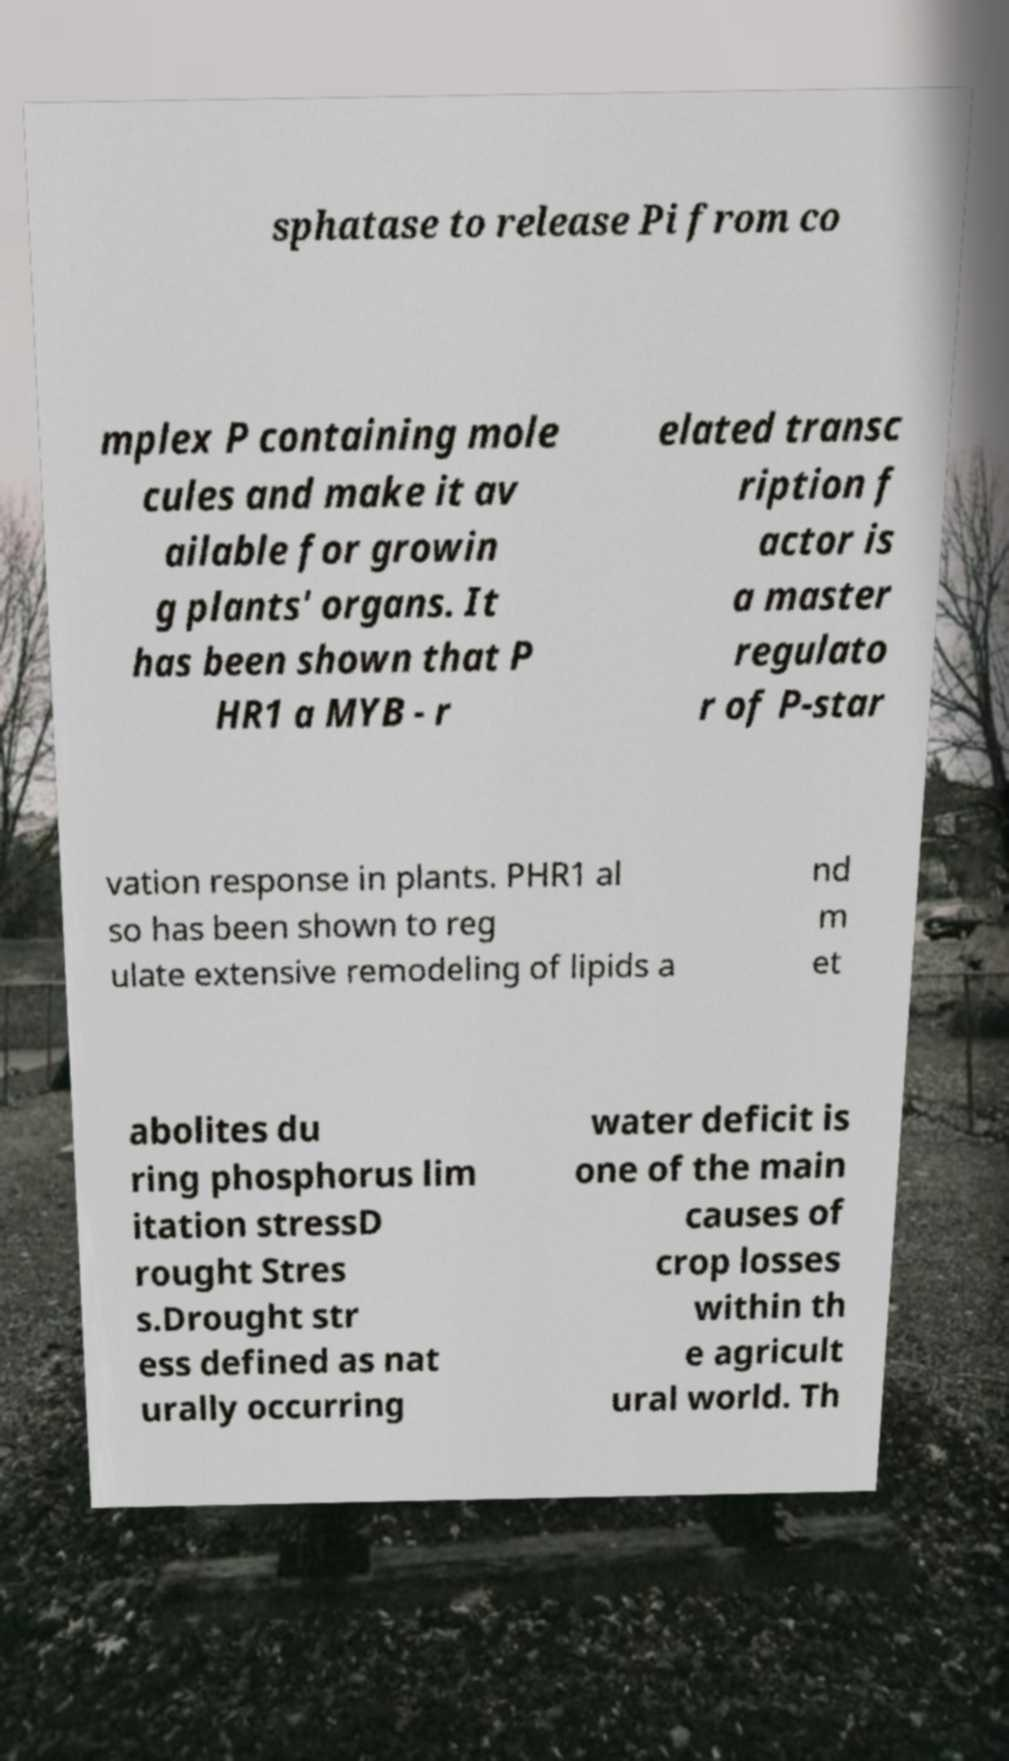What messages or text are displayed in this image? I need them in a readable, typed format. sphatase to release Pi from co mplex P containing mole cules and make it av ailable for growin g plants' organs. It has been shown that P HR1 a MYB - r elated transc ription f actor is a master regulato r of P-star vation response in plants. PHR1 al so has been shown to reg ulate extensive remodeling of lipids a nd m et abolites du ring phosphorus lim itation stressD rought Stres s.Drought str ess defined as nat urally occurring water deficit is one of the main causes of crop losses within th e agricult ural world. Th 